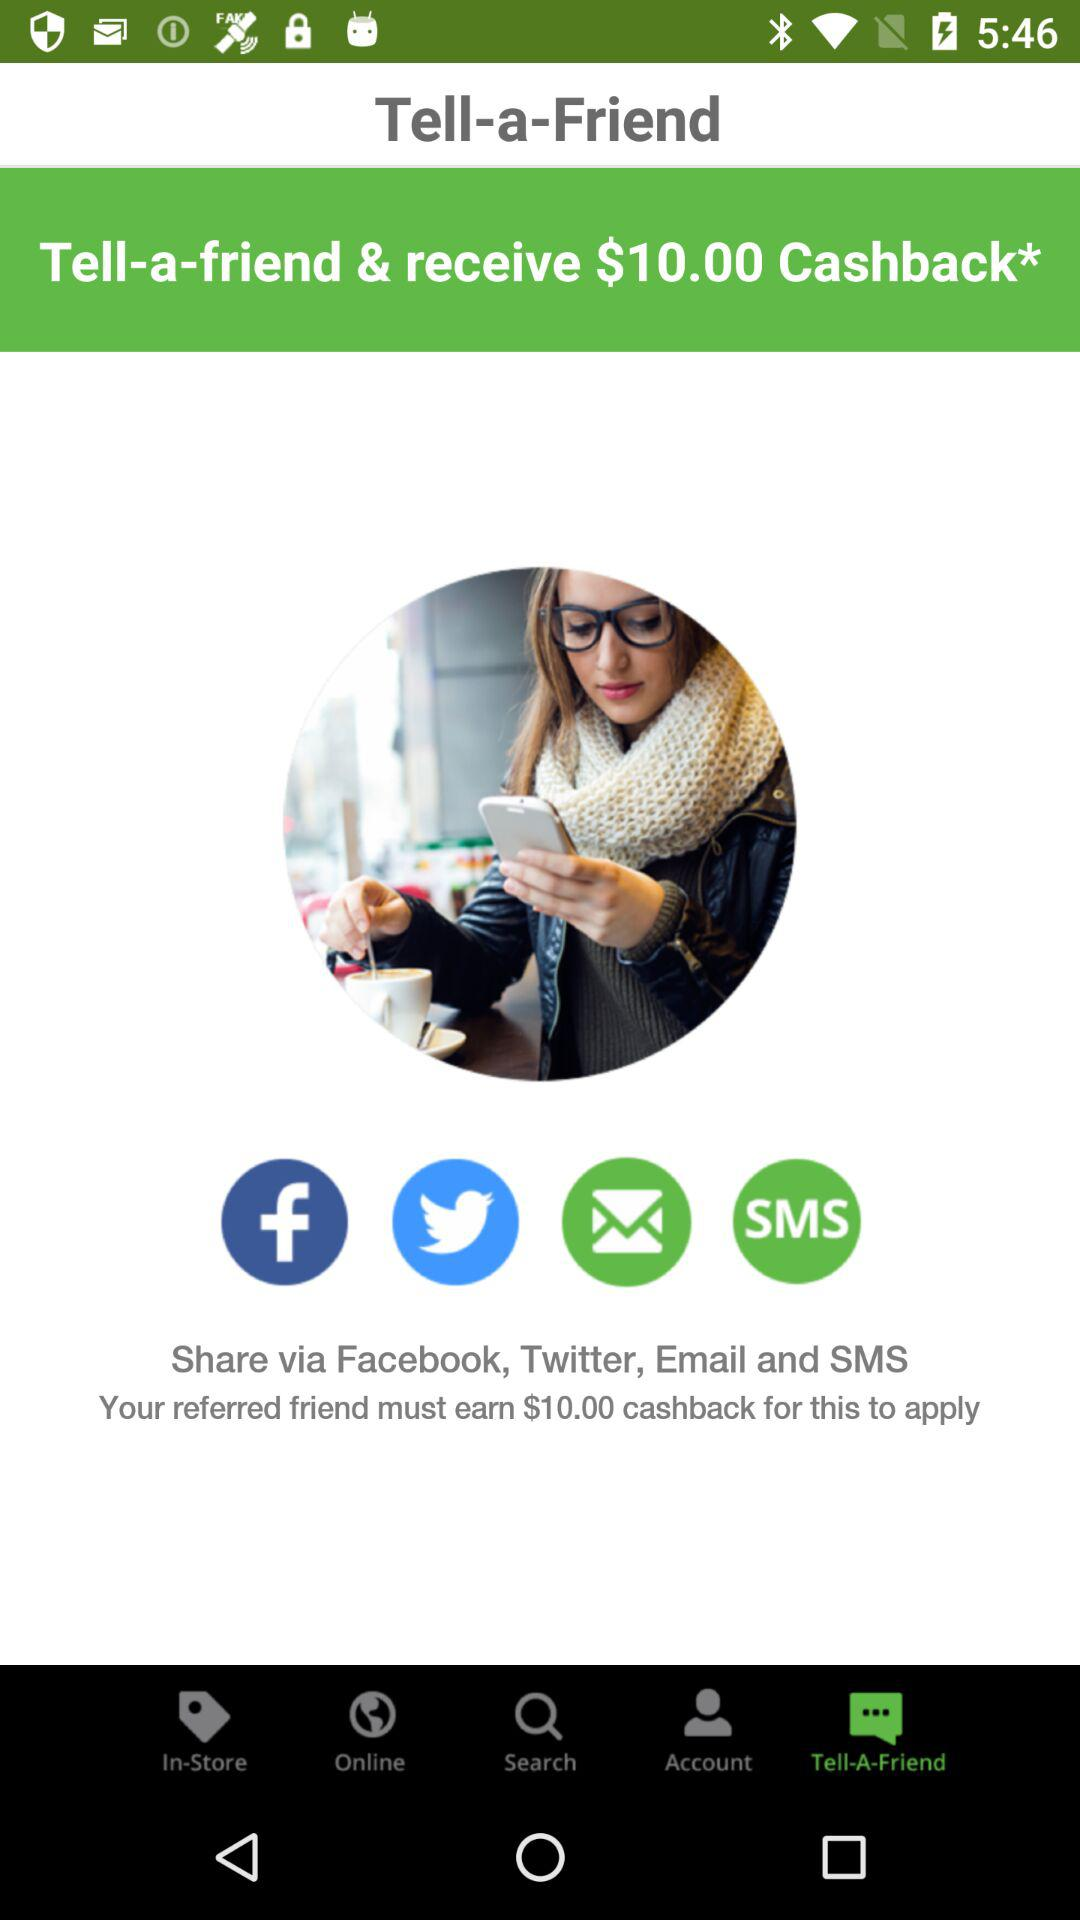How much cashback will be earned for referring friends? For referring friends, a cashback of $10.00 will be earned. 